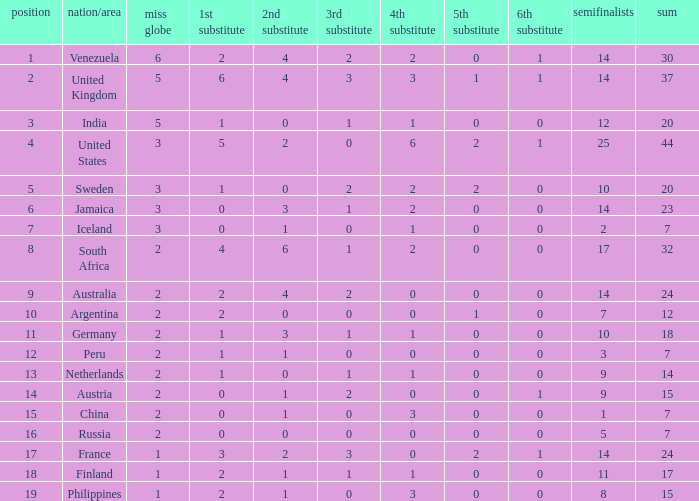What is the United States rank? 1.0. 